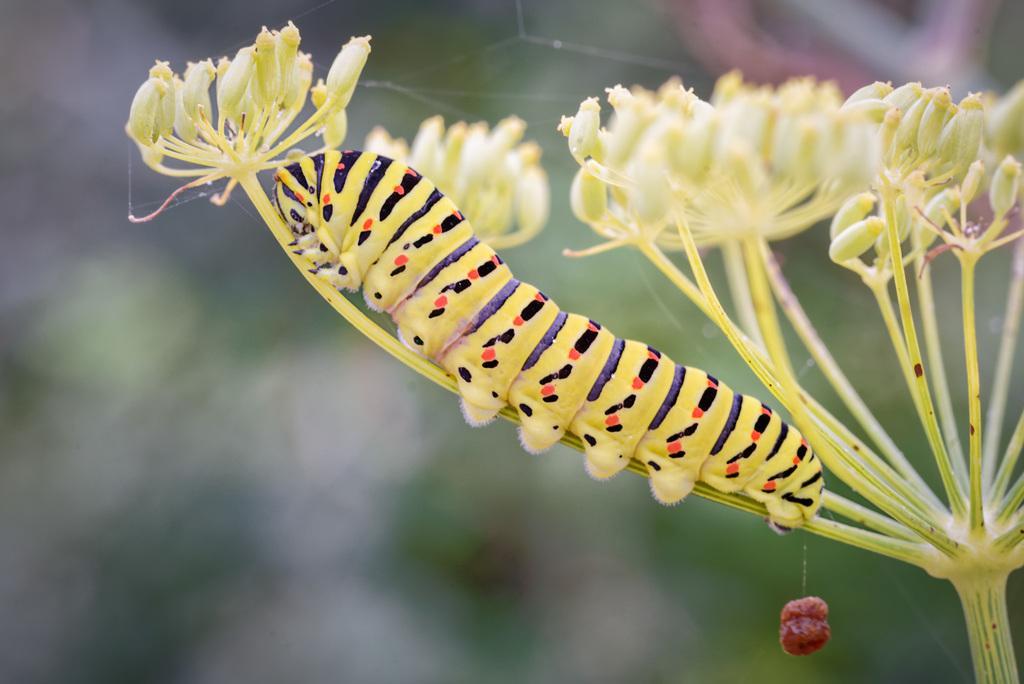How would you summarize this image in a sentence or two? In this image, we can see a plant with an insect and an object. We can also see the blurred background. 